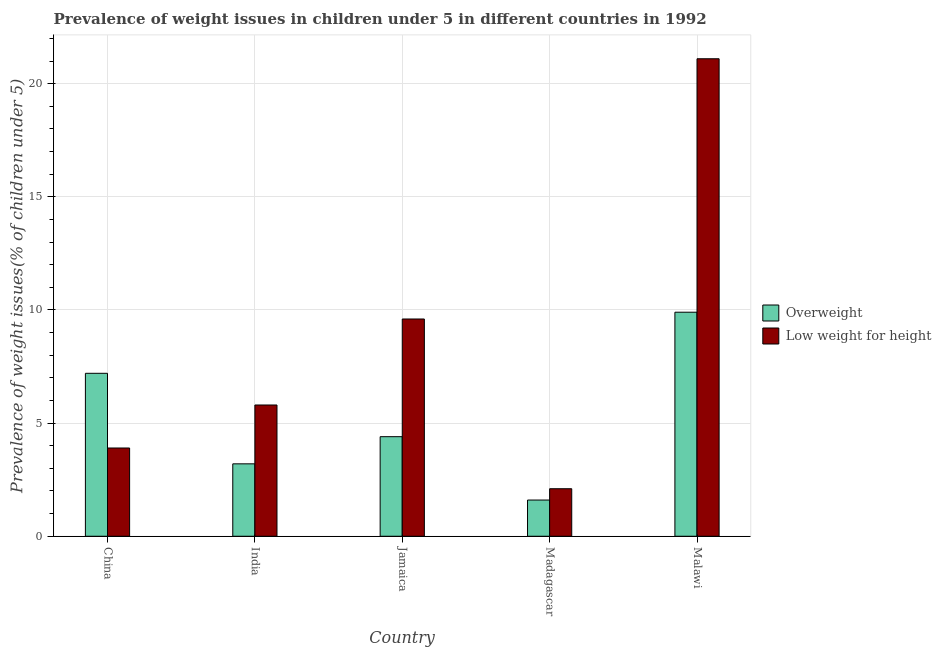How many different coloured bars are there?
Your answer should be very brief. 2. How many groups of bars are there?
Your answer should be compact. 5. How many bars are there on the 2nd tick from the left?
Keep it short and to the point. 2. How many bars are there on the 4th tick from the right?
Make the answer very short. 2. What is the label of the 5th group of bars from the left?
Your response must be concise. Malawi. What is the percentage of underweight children in Jamaica?
Offer a very short reply. 9.6. Across all countries, what is the maximum percentage of overweight children?
Provide a short and direct response. 9.9. Across all countries, what is the minimum percentage of underweight children?
Provide a succinct answer. 2.1. In which country was the percentage of overweight children maximum?
Offer a very short reply. Malawi. In which country was the percentage of overweight children minimum?
Your answer should be very brief. Madagascar. What is the total percentage of underweight children in the graph?
Your answer should be compact. 42.5. What is the difference between the percentage of underweight children in India and that in Malawi?
Offer a terse response. -15.3. What is the difference between the percentage of underweight children in Madagascar and the percentage of overweight children in Malawi?
Offer a very short reply. -7.8. What is the average percentage of overweight children per country?
Ensure brevity in your answer.  5.26. What is the difference between the percentage of underweight children and percentage of overweight children in India?
Keep it short and to the point. 2.6. What is the ratio of the percentage of overweight children in China to that in Jamaica?
Ensure brevity in your answer.  1.64. Is the percentage of overweight children in India less than that in Madagascar?
Offer a terse response. No. Is the difference between the percentage of overweight children in Jamaica and Madagascar greater than the difference between the percentage of underweight children in Jamaica and Madagascar?
Give a very brief answer. No. What is the difference between the highest and the second highest percentage of overweight children?
Your answer should be very brief. 2.7. What is the difference between the highest and the lowest percentage of overweight children?
Provide a short and direct response. 8.3. Is the sum of the percentage of underweight children in China and Malawi greater than the maximum percentage of overweight children across all countries?
Provide a short and direct response. Yes. What does the 1st bar from the left in China represents?
Keep it short and to the point. Overweight. What does the 2nd bar from the right in China represents?
Provide a short and direct response. Overweight. How many bars are there?
Ensure brevity in your answer.  10. How many countries are there in the graph?
Provide a short and direct response. 5. Are the values on the major ticks of Y-axis written in scientific E-notation?
Your answer should be very brief. No. Does the graph contain any zero values?
Give a very brief answer. No. Where does the legend appear in the graph?
Offer a terse response. Center right. What is the title of the graph?
Give a very brief answer. Prevalence of weight issues in children under 5 in different countries in 1992. What is the label or title of the Y-axis?
Offer a very short reply. Prevalence of weight issues(% of children under 5). What is the Prevalence of weight issues(% of children under 5) of Overweight in China?
Your answer should be compact. 7.2. What is the Prevalence of weight issues(% of children under 5) of Low weight for height in China?
Your response must be concise. 3.9. What is the Prevalence of weight issues(% of children under 5) of Overweight in India?
Keep it short and to the point. 3.2. What is the Prevalence of weight issues(% of children under 5) of Low weight for height in India?
Your response must be concise. 5.8. What is the Prevalence of weight issues(% of children under 5) of Overweight in Jamaica?
Make the answer very short. 4.4. What is the Prevalence of weight issues(% of children under 5) in Low weight for height in Jamaica?
Ensure brevity in your answer.  9.6. What is the Prevalence of weight issues(% of children under 5) of Overweight in Madagascar?
Offer a terse response. 1.6. What is the Prevalence of weight issues(% of children under 5) of Low weight for height in Madagascar?
Make the answer very short. 2.1. What is the Prevalence of weight issues(% of children under 5) in Overweight in Malawi?
Your answer should be very brief. 9.9. What is the Prevalence of weight issues(% of children under 5) of Low weight for height in Malawi?
Offer a terse response. 21.1. Across all countries, what is the maximum Prevalence of weight issues(% of children under 5) in Overweight?
Keep it short and to the point. 9.9. Across all countries, what is the maximum Prevalence of weight issues(% of children under 5) in Low weight for height?
Your response must be concise. 21.1. Across all countries, what is the minimum Prevalence of weight issues(% of children under 5) in Overweight?
Provide a short and direct response. 1.6. Across all countries, what is the minimum Prevalence of weight issues(% of children under 5) of Low weight for height?
Ensure brevity in your answer.  2.1. What is the total Prevalence of weight issues(% of children under 5) of Overweight in the graph?
Your response must be concise. 26.3. What is the total Prevalence of weight issues(% of children under 5) of Low weight for height in the graph?
Make the answer very short. 42.5. What is the difference between the Prevalence of weight issues(% of children under 5) in Overweight in China and that in Jamaica?
Offer a terse response. 2.8. What is the difference between the Prevalence of weight issues(% of children under 5) of Low weight for height in China and that in Madagascar?
Ensure brevity in your answer.  1.8. What is the difference between the Prevalence of weight issues(% of children under 5) of Low weight for height in China and that in Malawi?
Offer a very short reply. -17.2. What is the difference between the Prevalence of weight issues(% of children under 5) of Low weight for height in India and that in Jamaica?
Make the answer very short. -3.8. What is the difference between the Prevalence of weight issues(% of children under 5) in Low weight for height in India and that in Madagascar?
Provide a short and direct response. 3.7. What is the difference between the Prevalence of weight issues(% of children under 5) of Overweight in India and that in Malawi?
Make the answer very short. -6.7. What is the difference between the Prevalence of weight issues(% of children under 5) in Low weight for height in India and that in Malawi?
Offer a very short reply. -15.3. What is the difference between the Prevalence of weight issues(% of children under 5) in Low weight for height in Jamaica and that in Madagascar?
Keep it short and to the point. 7.5. What is the difference between the Prevalence of weight issues(% of children under 5) in Overweight in Jamaica and that in Malawi?
Keep it short and to the point. -5.5. What is the difference between the Prevalence of weight issues(% of children under 5) in Overweight in Madagascar and that in Malawi?
Your answer should be very brief. -8.3. What is the difference between the Prevalence of weight issues(% of children under 5) in Low weight for height in Madagascar and that in Malawi?
Offer a very short reply. -19. What is the difference between the Prevalence of weight issues(% of children under 5) of Overweight in China and the Prevalence of weight issues(% of children under 5) of Low weight for height in Jamaica?
Your answer should be compact. -2.4. What is the difference between the Prevalence of weight issues(% of children under 5) in Overweight in India and the Prevalence of weight issues(% of children under 5) in Low weight for height in Madagascar?
Your answer should be compact. 1.1. What is the difference between the Prevalence of weight issues(% of children under 5) in Overweight in India and the Prevalence of weight issues(% of children under 5) in Low weight for height in Malawi?
Make the answer very short. -17.9. What is the difference between the Prevalence of weight issues(% of children under 5) in Overweight in Jamaica and the Prevalence of weight issues(% of children under 5) in Low weight for height in Madagascar?
Make the answer very short. 2.3. What is the difference between the Prevalence of weight issues(% of children under 5) in Overweight in Jamaica and the Prevalence of weight issues(% of children under 5) in Low weight for height in Malawi?
Offer a very short reply. -16.7. What is the difference between the Prevalence of weight issues(% of children under 5) of Overweight in Madagascar and the Prevalence of weight issues(% of children under 5) of Low weight for height in Malawi?
Provide a succinct answer. -19.5. What is the average Prevalence of weight issues(% of children under 5) in Overweight per country?
Make the answer very short. 5.26. What is the difference between the Prevalence of weight issues(% of children under 5) in Overweight and Prevalence of weight issues(% of children under 5) in Low weight for height in India?
Your response must be concise. -2.6. What is the ratio of the Prevalence of weight issues(% of children under 5) of Overweight in China to that in India?
Your response must be concise. 2.25. What is the ratio of the Prevalence of weight issues(% of children under 5) in Low weight for height in China to that in India?
Your response must be concise. 0.67. What is the ratio of the Prevalence of weight issues(% of children under 5) in Overweight in China to that in Jamaica?
Your answer should be very brief. 1.64. What is the ratio of the Prevalence of weight issues(% of children under 5) of Low weight for height in China to that in Jamaica?
Provide a short and direct response. 0.41. What is the ratio of the Prevalence of weight issues(% of children under 5) in Low weight for height in China to that in Madagascar?
Your answer should be compact. 1.86. What is the ratio of the Prevalence of weight issues(% of children under 5) of Overweight in China to that in Malawi?
Keep it short and to the point. 0.73. What is the ratio of the Prevalence of weight issues(% of children under 5) in Low weight for height in China to that in Malawi?
Your response must be concise. 0.18. What is the ratio of the Prevalence of weight issues(% of children under 5) of Overweight in India to that in Jamaica?
Provide a short and direct response. 0.73. What is the ratio of the Prevalence of weight issues(% of children under 5) of Low weight for height in India to that in Jamaica?
Offer a very short reply. 0.6. What is the ratio of the Prevalence of weight issues(% of children under 5) in Low weight for height in India to that in Madagascar?
Offer a terse response. 2.76. What is the ratio of the Prevalence of weight issues(% of children under 5) in Overweight in India to that in Malawi?
Keep it short and to the point. 0.32. What is the ratio of the Prevalence of weight issues(% of children under 5) in Low weight for height in India to that in Malawi?
Make the answer very short. 0.27. What is the ratio of the Prevalence of weight issues(% of children under 5) of Overweight in Jamaica to that in Madagascar?
Your answer should be very brief. 2.75. What is the ratio of the Prevalence of weight issues(% of children under 5) of Low weight for height in Jamaica to that in Madagascar?
Your response must be concise. 4.57. What is the ratio of the Prevalence of weight issues(% of children under 5) of Overweight in Jamaica to that in Malawi?
Offer a terse response. 0.44. What is the ratio of the Prevalence of weight issues(% of children under 5) in Low weight for height in Jamaica to that in Malawi?
Your response must be concise. 0.46. What is the ratio of the Prevalence of weight issues(% of children under 5) of Overweight in Madagascar to that in Malawi?
Make the answer very short. 0.16. What is the ratio of the Prevalence of weight issues(% of children under 5) in Low weight for height in Madagascar to that in Malawi?
Provide a short and direct response. 0.1. What is the difference between the highest and the second highest Prevalence of weight issues(% of children under 5) in Overweight?
Your answer should be compact. 2.7. What is the difference between the highest and the second highest Prevalence of weight issues(% of children under 5) of Low weight for height?
Offer a very short reply. 11.5. 